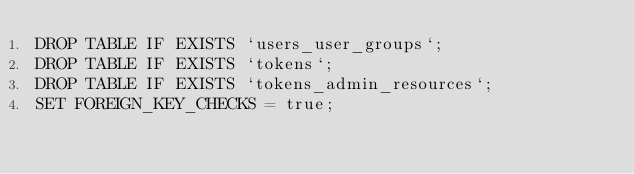<code> <loc_0><loc_0><loc_500><loc_500><_SQL_>DROP TABLE IF EXISTS `users_user_groups`;
DROP TABLE IF EXISTS `tokens`;
DROP TABLE IF EXISTS `tokens_admin_resources`;
SET FOREIGN_KEY_CHECKS = true;
</code> 